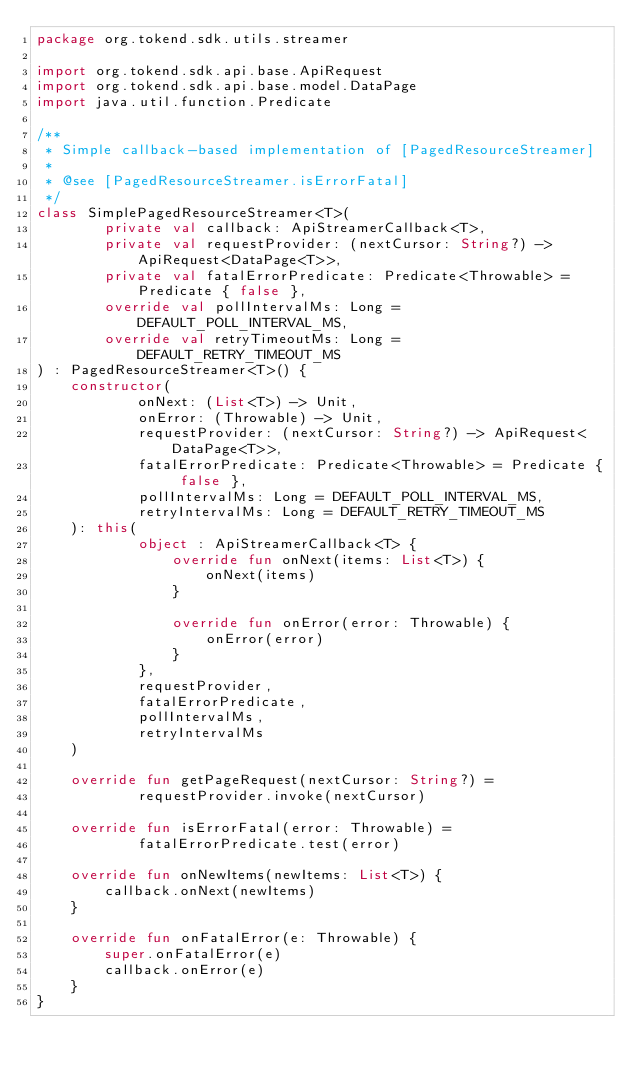<code> <loc_0><loc_0><loc_500><loc_500><_Kotlin_>package org.tokend.sdk.utils.streamer

import org.tokend.sdk.api.base.ApiRequest
import org.tokend.sdk.api.base.model.DataPage
import java.util.function.Predicate

/**
 * Simple callback-based implementation of [PagedResourceStreamer]
 *
 * @see [PagedResourceStreamer.isErrorFatal]
 */
class SimplePagedResourceStreamer<T>(
        private val callback: ApiStreamerCallback<T>,
        private val requestProvider: (nextCursor: String?) -> ApiRequest<DataPage<T>>,
        private val fatalErrorPredicate: Predicate<Throwable> = Predicate { false },
        override val pollIntervalMs: Long = DEFAULT_POLL_INTERVAL_MS,
        override val retryTimeoutMs: Long = DEFAULT_RETRY_TIMEOUT_MS
) : PagedResourceStreamer<T>() {
    constructor(
            onNext: (List<T>) -> Unit,
            onError: (Throwable) -> Unit,
            requestProvider: (nextCursor: String?) -> ApiRequest<DataPage<T>>,
            fatalErrorPredicate: Predicate<Throwable> = Predicate { false },
            pollIntervalMs: Long = DEFAULT_POLL_INTERVAL_MS,
            retryIntervalMs: Long = DEFAULT_RETRY_TIMEOUT_MS
    ): this(
            object : ApiStreamerCallback<T> {
                override fun onNext(items: List<T>) {
                    onNext(items)
                }

                override fun onError(error: Throwable) {
                    onError(error)
                }
            },
            requestProvider,
            fatalErrorPredicate,
            pollIntervalMs,
            retryIntervalMs
    )

    override fun getPageRequest(nextCursor: String?) =
            requestProvider.invoke(nextCursor)

    override fun isErrorFatal(error: Throwable) =
            fatalErrorPredicate.test(error)

    override fun onNewItems(newItems: List<T>) {
        callback.onNext(newItems)
    }

    override fun onFatalError(e: Throwable) {
        super.onFatalError(e)
        callback.onError(e)
    }
}</code> 